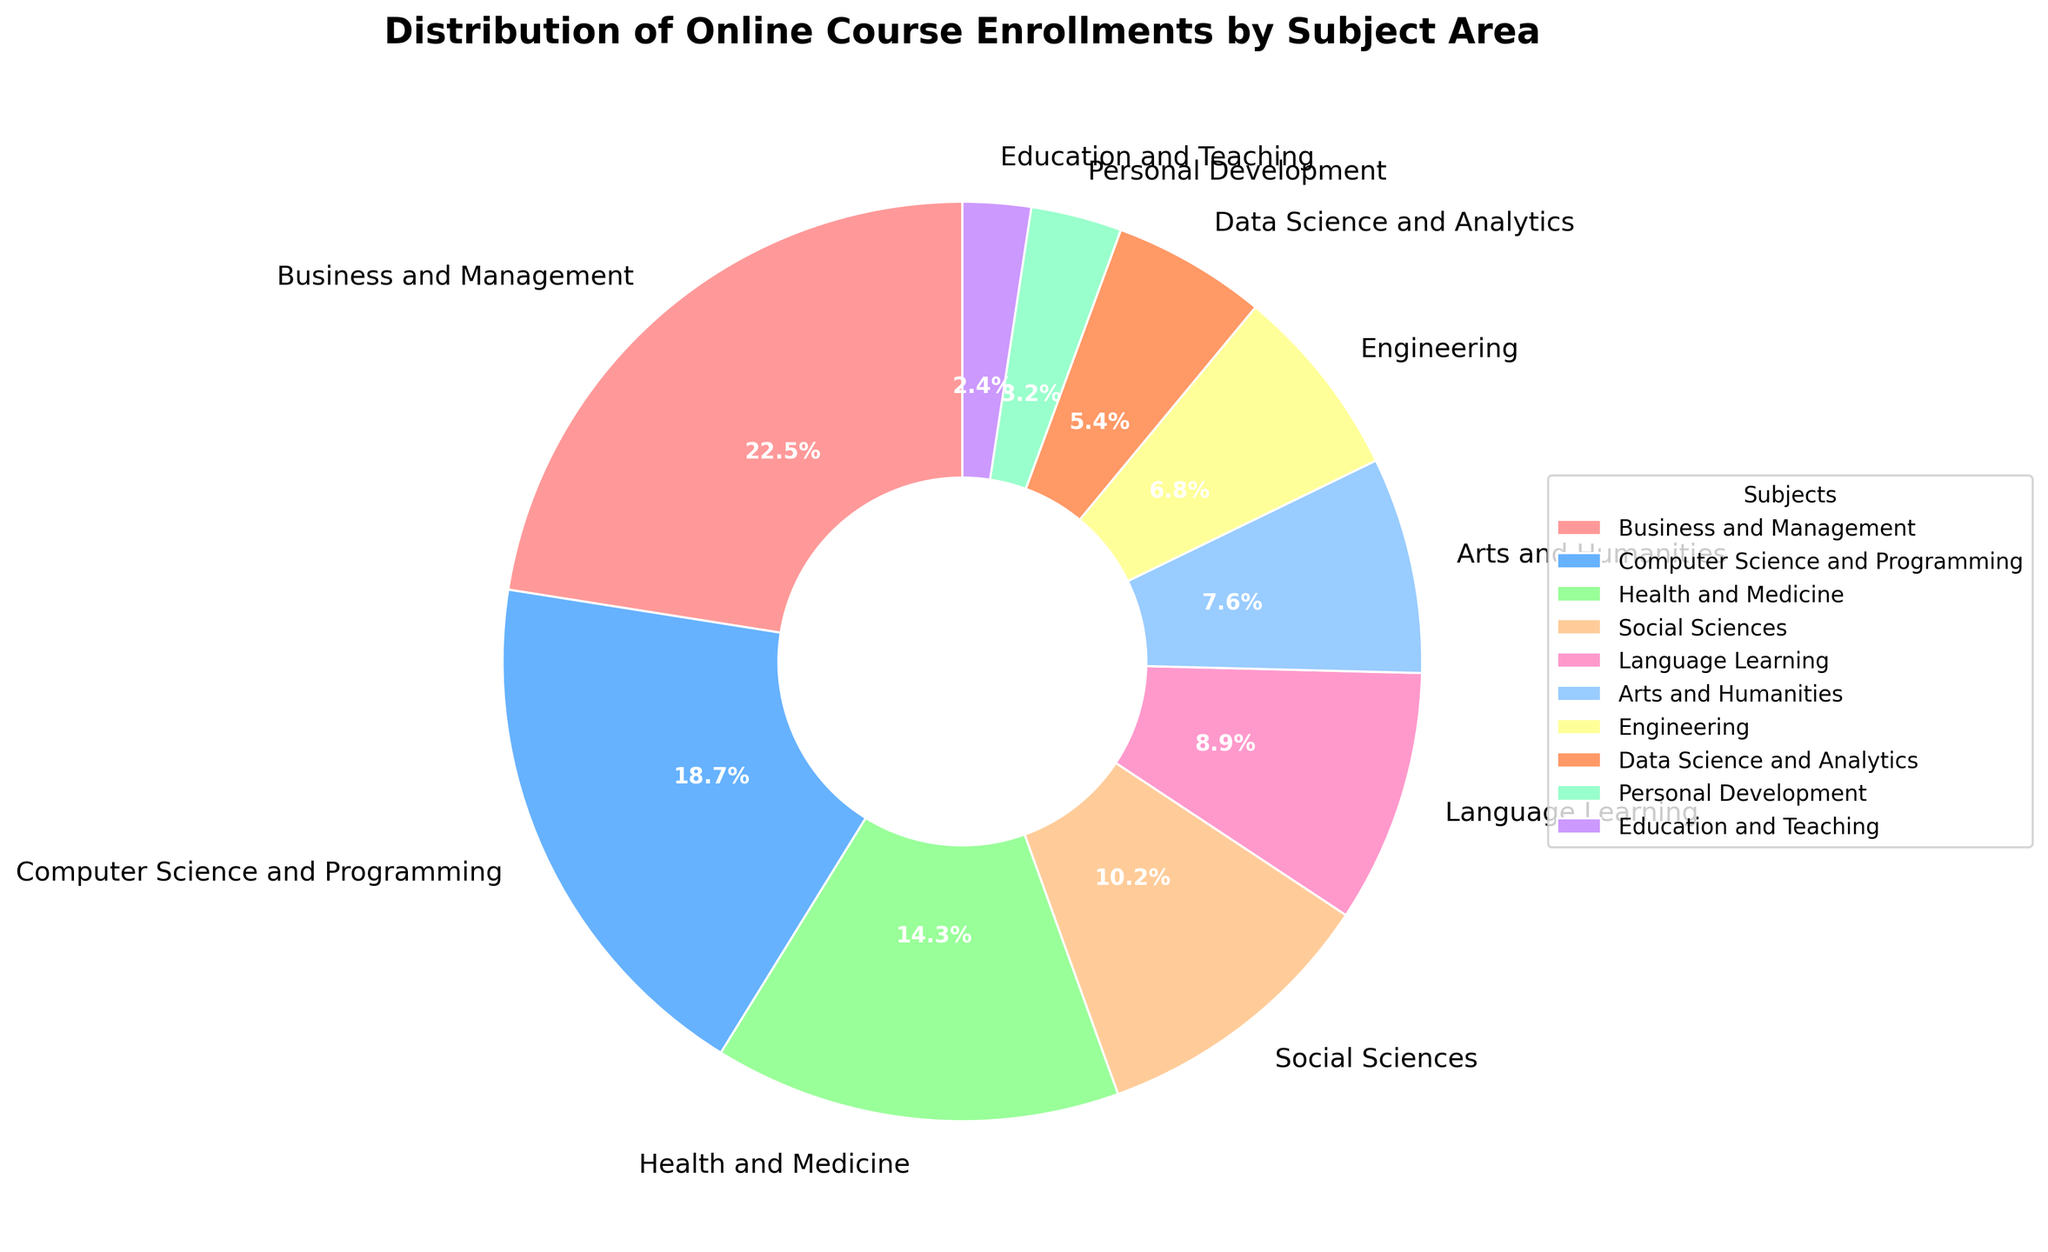What subject area has the highest enrollment percentage? The figure displays a pie chart with various slices representing different subject areas. The slice labeled "Business and Management" is the largest, indicating it has the highest enrollment percentage.
Answer: Business and Management How much larger is the enrollment percentage for Business and Management compared to Education and Teaching? To find the difference, subtract the enrollment percentage for Education and Teaching (2.4%) from that of Business and Management (22.5%): 22.5% - 2.4% = 20.1%.
Answer: 20.1% Which subject area has a smaller enrollment percentage: Arts and Humanities, or Health and Medicine? The chart shows that Arts and Humanities have an enrollment percentage of 7.6%, while Health and Medicine have 14.3%. Since 7.6% is smaller than 14.3%, Arts and Humanities have a smaller enrollment percentage.
Answer: Arts and Humanities What is the combined enrollment percentage for Computer Science and Programming, and Data Science and Analytics? Sum the enrollment percentages for Computer Science and Programming (18.7%) and Data Science and Analytics (5.4%): 18.7% + 5.4% = 24.1%.
Answer: 24.1% Which subject areas occupy slices with a red or pink hue in the pie chart, and what are their respective enrollment percentages? From the visual attributes of the chart, the red or pink hues are distributed among the subjects: Business and Management (22.5%) and Education and Teaching (2.4%).
Answer: Business and Management: 22.5%, Education and Teaching: 2.4% How does the enrollment percentage for Social Sciences compare to that for Language Learning? The chart indicates that Social Sciences have an enrollment percentage of 10.2%, while Language Learning has 8.9%. Since 10.2% is greater than 8.9%, Social Sciences have a higher enrollment percentage.
Answer: Social Sciences If we combine the enrollment percentages of the three least enrolled subject areas, what is the total? The three least enrolled subject areas are Education and Teaching (2.4%), Personal Development (3.2%), and Data Science and Analytics (5.4%). Their combined enrollment percentage is 2.4% + 3.2% + 5.4% = 11%.
Answer: 11% What is the average enrollment percentage across all subject areas? Sum all the enrollment percentages: 22.5% + 18.7% + 14.3% + 10.2% + 8.9% + 7.6% + 6.8% + 5.4% + 3.2% + 2.4% = 100%. Since there are 10 subject areas, the average is 100% / 10 = 10%.
Answer: 10% Between Engineering and Personal Development, which subject has a higher enrollment percentage and by how much? The enrollment percentage for Engineering is 6.8% and for Personal Development is 3.2%. To find the difference: 6.8% - 3.2% = 3.6%. Engineering has a higher enrollment by 3.6%.
Answer: Engineering by 3.6% Which color represents Language Learning in the pie chart? Visually identify the slice labeled "Language Learning" and its associated color. The chart shows Language Learning is represented with a light brown color.
Answer: Light brown 